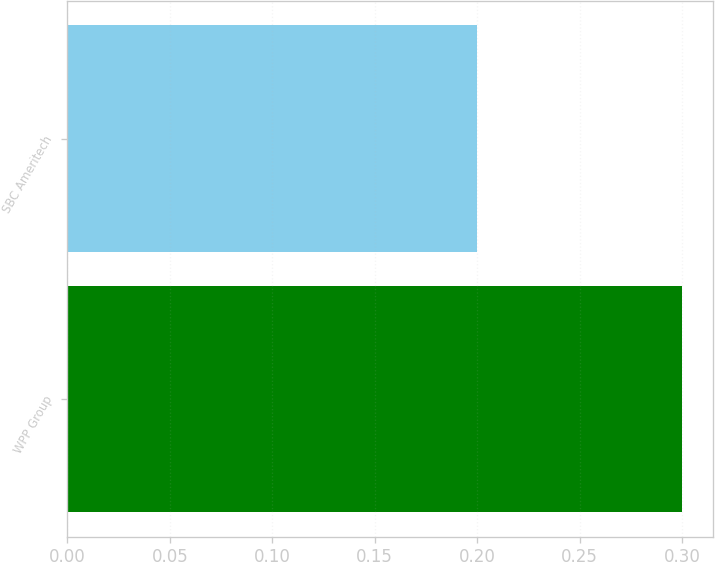Convert chart to OTSL. <chart><loc_0><loc_0><loc_500><loc_500><bar_chart><fcel>WPP Group<fcel>SBC Ameritech<nl><fcel>0.3<fcel>0.2<nl></chart> 